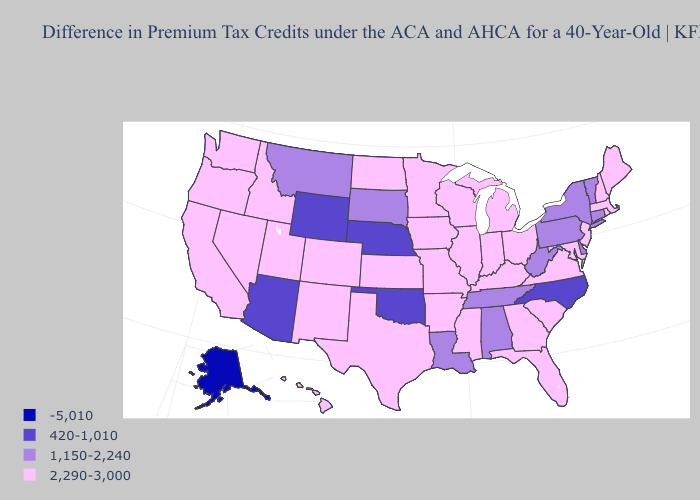Name the states that have a value in the range 420-1,010?
Keep it brief. Arizona, Nebraska, North Carolina, Oklahoma, Wyoming. Does North Carolina have the highest value in the USA?
Quick response, please. No. Does Hawaii have the highest value in the West?
Give a very brief answer. Yes. What is the value of New Jersey?
Short answer required. 2,290-3,000. What is the highest value in the USA?
Answer briefly. 2,290-3,000. What is the lowest value in the USA?
Keep it brief. -5,010. How many symbols are there in the legend?
Quick response, please. 4. What is the value of Mississippi?
Concise answer only. 2,290-3,000. What is the value of South Carolina?
Give a very brief answer. 2,290-3,000. Does the map have missing data?
Concise answer only. No. Does New Jersey have the lowest value in the Northeast?
Concise answer only. No. What is the value of Oklahoma?
Answer briefly. 420-1,010. What is the value of Connecticut?
Answer briefly. 1,150-2,240. Name the states that have a value in the range 1,150-2,240?
Keep it brief. Alabama, Connecticut, Delaware, Louisiana, Montana, New York, Pennsylvania, South Dakota, Tennessee, Vermont, West Virginia. Name the states that have a value in the range 1,150-2,240?
Concise answer only. Alabama, Connecticut, Delaware, Louisiana, Montana, New York, Pennsylvania, South Dakota, Tennessee, Vermont, West Virginia. 